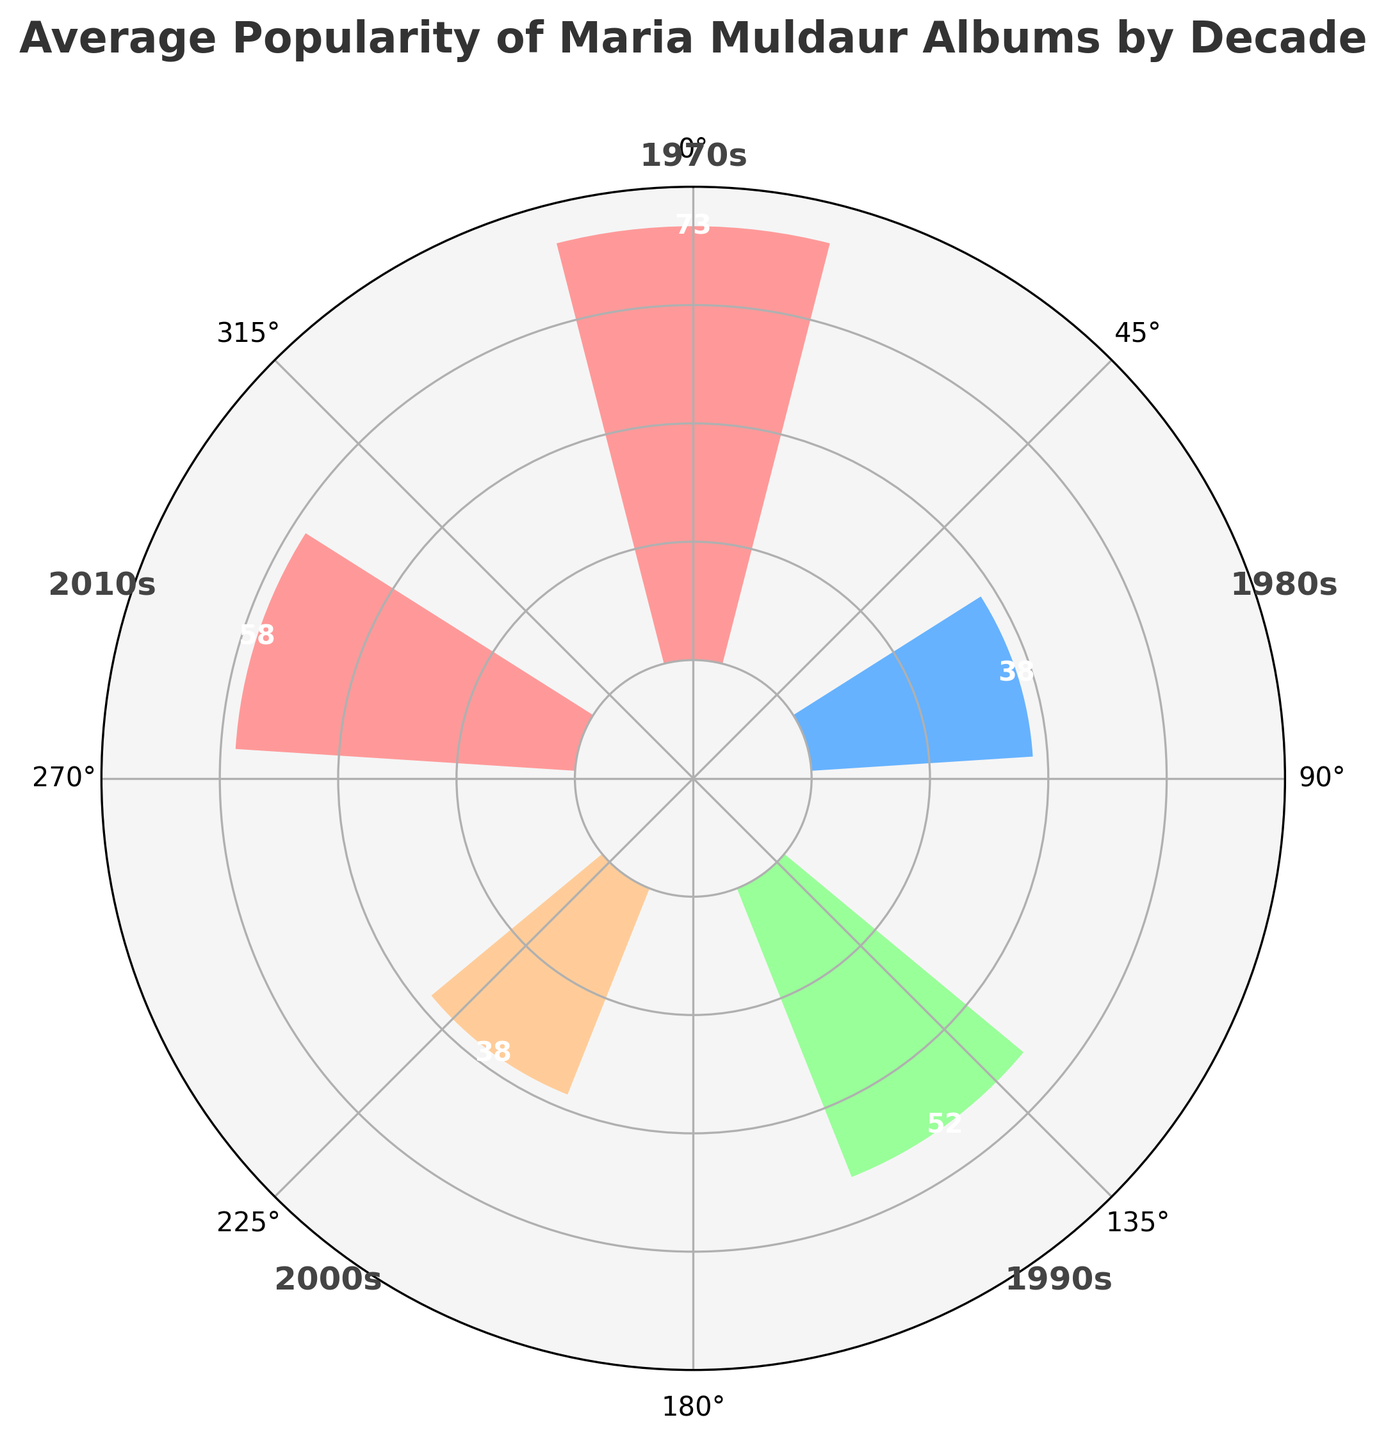What's the title of the figure? The title of the figure is typically located at the top and is displayed in bold and larger font. The title reads, "Average Popularity of Maria Muldaur Albums by Decade".
Answer: Average Popularity of Maria Muldaur Albums by Decade How many decades are represented in the chart? By looking at the labels around the plot, for example, 1970s, 1980s, 1990s, and 2000s, we can count the number.
Answer: 4 Which decade had the highest average popularity for Maria Muldaur's albums? Observe the bars in the rose chart and identify the one with the highest length. The bar representing the 1970s is the longest.
Answer: 1970s What's the average popularity value for the 2010s? The value is displayed at the top of the bar for the 2010s. We can read this value directly.
Answer: 57.5 Is there a decade where the average popularity of albums is below 50? Check each bar and read the average popularity values. The bars for the 1980s (35) indicate values below 50.
Answer: Yes, the 1980s What's the average popularity difference between the 1970s and the 1990s? Subtract the average value of the 1990s bar (52.5) from the 1970s one (73.3): 73.3 - 52.5 = 20.8
Answer: 20.8 Which two decades have the closest average popularity values? Compare the values of bars adjacent to each other and find the two closest. The 2010s (57.5) and the 1990s (52.5) have values closest to each other with a difference of 5.
Answer: 2010s and 1990s What color represents the decade with the lowest average popularity? Identify the bar with the lowest value (1980s) and note its color, which is blue.
Answer: Blue How is the angle direction in the rose chart arranged, clockwise or counterclockwise? The rose chart's angle direction is arranged counterclockwise, with 0° at the top and progressing in the opposite direction of a clock's hands.
Answer: Counterclockwise What is the difference in average popularity between the top two decades? Identify the two highest bars: 1970s (73.3) and 2010s (57.5), then find the difference: 73.3 - 57.5 = 15.8
Answer: 15.8 